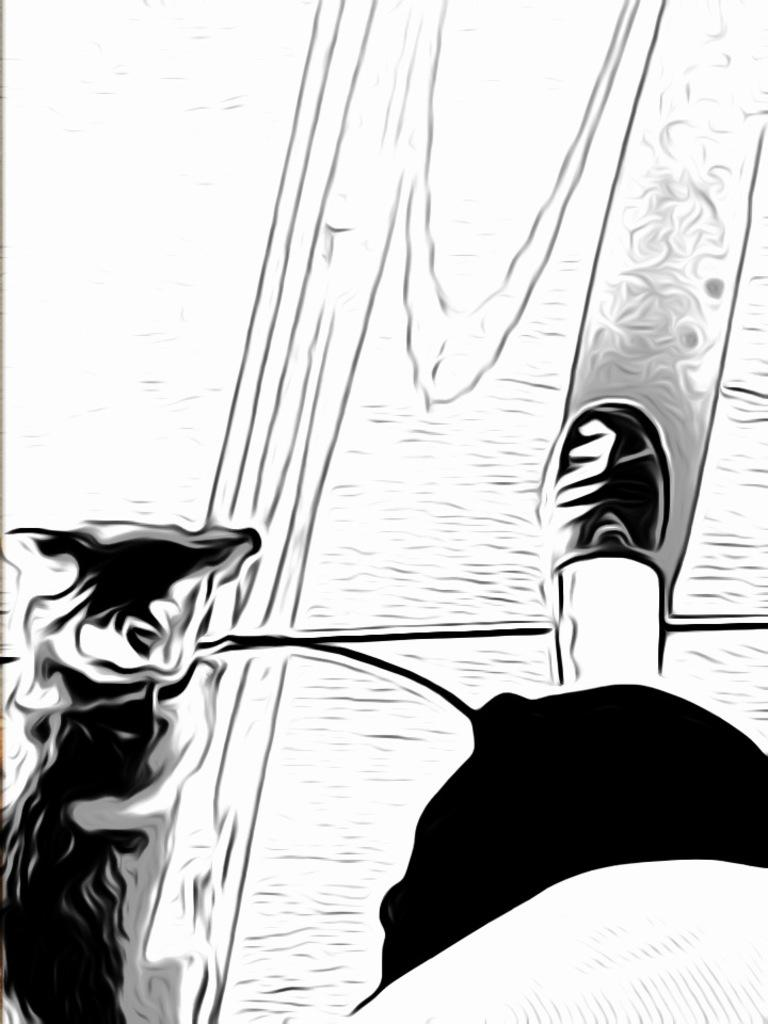What is the main subject of the image? There is a drawing in the center of the image. What part of a person is depicted in the drawing? The drawing includes a leg of a person. Are there any other objects or elements in the drawing? Yes, there are a few other objects in the drawing. What type of tray is being used by the students during recess in the image? There is no reference to a tray, students, or recess in the image, as it only features a drawing with a leg and a few other objects. 